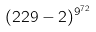<formula> <loc_0><loc_0><loc_500><loc_500>( 2 2 9 - 2 ) ^ { 9 ^ { 7 2 } }</formula> 